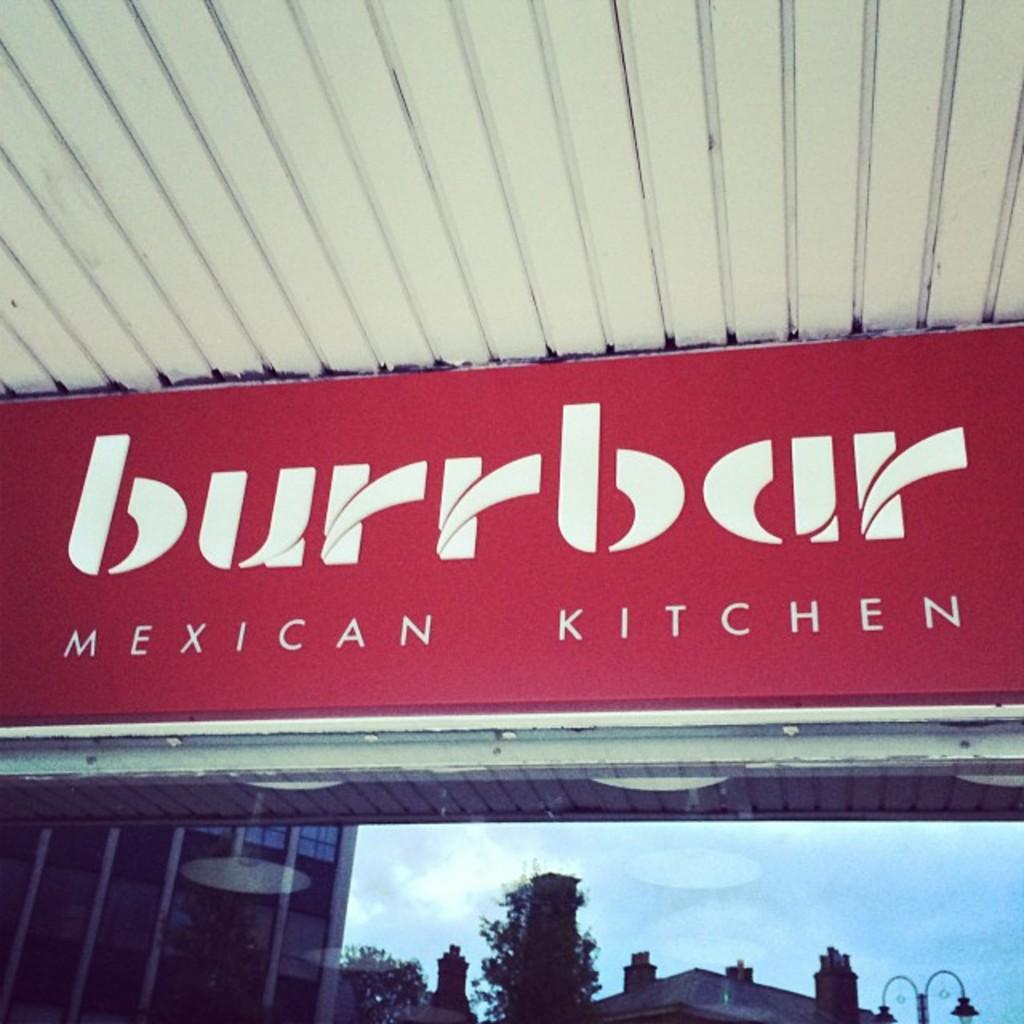<image>
Offer a succinct explanation of the picture presented. A red and white sign for Burrbar Mexican Kitchen. 